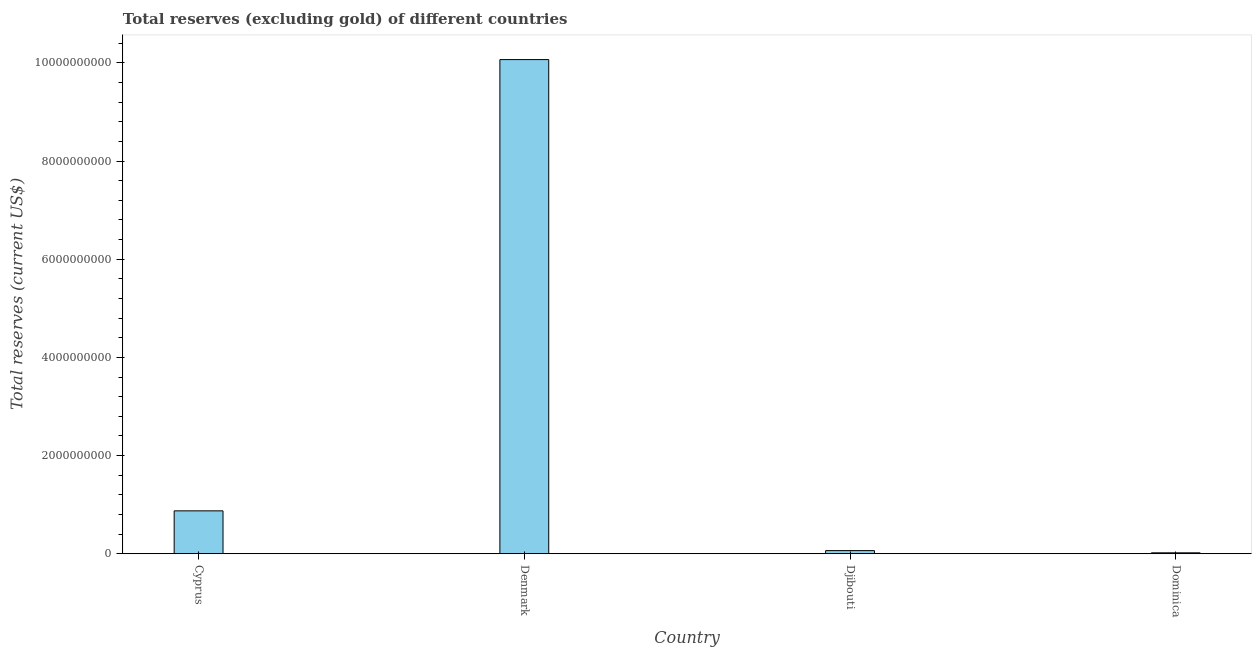Does the graph contain grids?
Give a very brief answer. No. What is the title of the graph?
Your answer should be compact. Total reserves (excluding gold) of different countries. What is the label or title of the Y-axis?
Give a very brief answer. Total reserves (current US$). What is the total reserves (excluding gold) in Dominica?
Provide a succinct answer. 1.84e+07. Across all countries, what is the maximum total reserves (excluding gold)?
Provide a short and direct response. 1.01e+1. Across all countries, what is the minimum total reserves (excluding gold)?
Your answer should be compact. 1.84e+07. In which country was the total reserves (excluding gold) minimum?
Offer a terse response. Dominica. What is the sum of the total reserves (excluding gold)?
Give a very brief answer. 1.10e+1. What is the difference between the total reserves (excluding gold) in Cyprus and Dominica?
Offer a very short reply. 8.55e+08. What is the average total reserves (excluding gold) per country?
Provide a succinct answer. 2.76e+09. What is the median total reserves (excluding gold)?
Your response must be concise. 4.69e+08. What is the ratio of the total reserves (excluding gold) in Cyprus to that in Djibouti?
Provide a succinct answer. 13.75. Is the total reserves (excluding gold) in Denmark less than that in Djibouti?
Give a very brief answer. No. What is the difference between the highest and the second highest total reserves (excluding gold)?
Make the answer very short. 9.19e+09. Is the sum of the total reserves (excluding gold) in Djibouti and Dominica greater than the maximum total reserves (excluding gold) across all countries?
Keep it short and to the point. No. What is the difference between the highest and the lowest total reserves (excluding gold)?
Keep it short and to the point. 1.00e+1. What is the difference between two consecutive major ticks on the Y-axis?
Make the answer very short. 2.00e+09. Are the values on the major ticks of Y-axis written in scientific E-notation?
Your response must be concise. No. What is the Total reserves (current US$) of Cyprus?
Your answer should be compact. 8.74e+08. What is the Total reserves (current US$) in Denmark?
Your response must be concise. 1.01e+1. What is the Total reserves (current US$) of Djibouti?
Ensure brevity in your answer.  6.35e+07. What is the Total reserves (current US$) of Dominica?
Your response must be concise. 1.84e+07. What is the difference between the Total reserves (current US$) in Cyprus and Denmark?
Keep it short and to the point. -9.19e+09. What is the difference between the Total reserves (current US$) in Cyprus and Djibouti?
Offer a very short reply. 8.10e+08. What is the difference between the Total reserves (current US$) in Cyprus and Dominica?
Your answer should be compact. 8.55e+08. What is the difference between the Total reserves (current US$) in Denmark and Djibouti?
Your answer should be very brief. 1.00e+1. What is the difference between the Total reserves (current US$) in Denmark and Dominica?
Provide a succinct answer. 1.00e+1. What is the difference between the Total reserves (current US$) in Djibouti and Dominica?
Keep it short and to the point. 4.51e+07. What is the ratio of the Total reserves (current US$) in Cyprus to that in Denmark?
Your response must be concise. 0.09. What is the ratio of the Total reserves (current US$) in Cyprus to that in Djibouti?
Your answer should be very brief. 13.75. What is the ratio of the Total reserves (current US$) in Cyprus to that in Dominica?
Your answer should be compact. 47.4. What is the ratio of the Total reserves (current US$) in Denmark to that in Djibouti?
Give a very brief answer. 158.46. What is the ratio of the Total reserves (current US$) in Denmark to that in Dominica?
Give a very brief answer. 546.28. What is the ratio of the Total reserves (current US$) in Djibouti to that in Dominica?
Give a very brief answer. 3.45. 